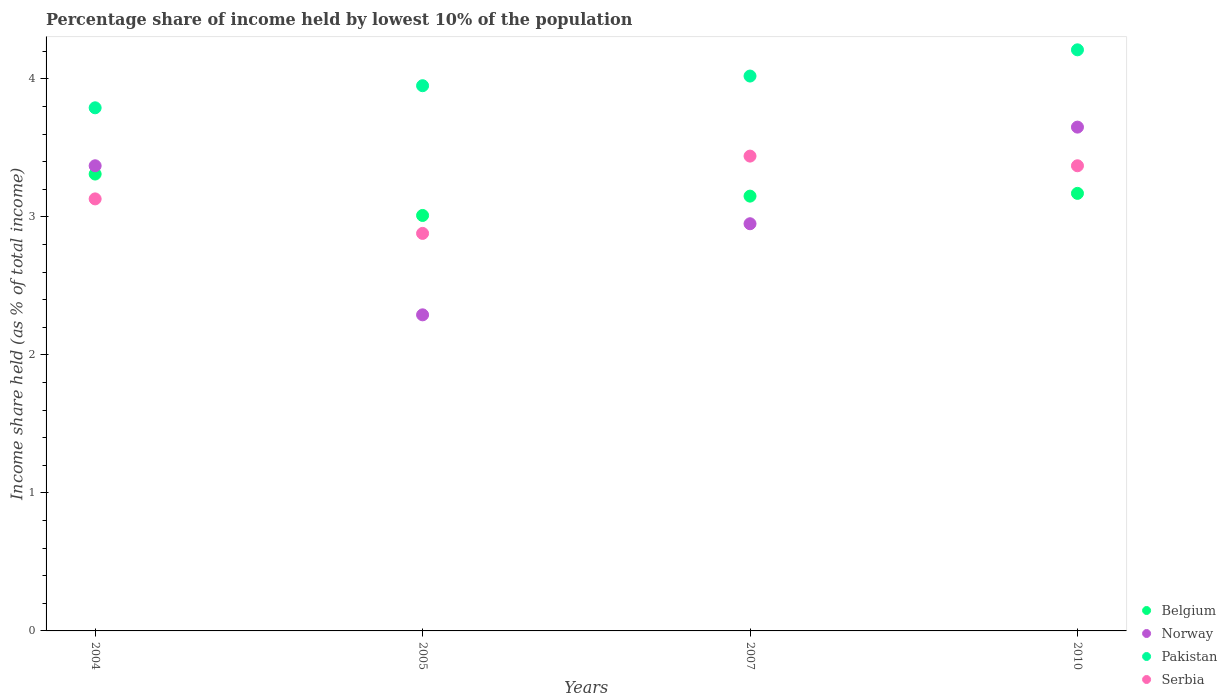Is the number of dotlines equal to the number of legend labels?
Your response must be concise. Yes. What is the percentage share of income held by lowest 10% of the population in Pakistan in 2005?
Offer a terse response. 3.95. Across all years, what is the maximum percentage share of income held by lowest 10% of the population in Belgium?
Offer a very short reply. 3.31. Across all years, what is the minimum percentage share of income held by lowest 10% of the population in Norway?
Offer a very short reply. 2.29. In which year was the percentage share of income held by lowest 10% of the population in Norway maximum?
Make the answer very short. 2010. What is the total percentage share of income held by lowest 10% of the population in Norway in the graph?
Keep it short and to the point. 12.26. What is the difference between the percentage share of income held by lowest 10% of the population in Serbia in 2004 and that in 2005?
Offer a very short reply. 0.25. What is the difference between the percentage share of income held by lowest 10% of the population in Pakistan in 2004 and the percentage share of income held by lowest 10% of the population in Norway in 2010?
Your answer should be compact. 0.14. What is the average percentage share of income held by lowest 10% of the population in Belgium per year?
Provide a short and direct response. 3.16. In the year 2010, what is the difference between the percentage share of income held by lowest 10% of the population in Norway and percentage share of income held by lowest 10% of the population in Serbia?
Give a very brief answer. 0.28. What is the ratio of the percentage share of income held by lowest 10% of the population in Pakistan in 2007 to that in 2010?
Provide a short and direct response. 0.95. What is the difference between the highest and the second highest percentage share of income held by lowest 10% of the population in Belgium?
Give a very brief answer. 0.14. What is the difference between the highest and the lowest percentage share of income held by lowest 10% of the population in Norway?
Give a very brief answer. 1.36. In how many years, is the percentage share of income held by lowest 10% of the population in Belgium greater than the average percentage share of income held by lowest 10% of the population in Belgium taken over all years?
Make the answer very short. 2. Is it the case that in every year, the sum of the percentage share of income held by lowest 10% of the population in Pakistan and percentage share of income held by lowest 10% of the population in Norway  is greater than the sum of percentage share of income held by lowest 10% of the population in Serbia and percentage share of income held by lowest 10% of the population in Belgium?
Provide a short and direct response. No. Is it the case that in every year, the sum of the percentage share of income held by lowest 10% of the population in Norway and percentage share of income held by lowest 10% of the population in Pakistan  is greater than the percentage share of income held by lowest 10% of the population in Serbia?
Keep it short and to the point. Yes. How many dotlines are there?
Your answer should be very brief. 4. Does the graph contain any zero values?
Offer a very short reply. No. Where does the legend appear in the graph?
Provide a short and direct response. Bottom right. How many legend labels are there?
Your answer should be very brief. 4. What is the title of the graph?
Make the answer very short. Percentage share of income held by lowest 10% of the population. What is the label or title of the Y-axis?
Provide a succinct answer. Income share held (as % of total income). What is the Income share held (as % of total income) of Belgium in 2004?
Offer a very short reply. 3.31. What is the Income share held (as % of total income) in Norway in 2004?
Give a very brief answer. 3.37. What is the Income share held (as % of total income) of Pakistan in 2004?
Give a very brief answer. 3.79. What is the Income share held (as % of total income) in Serbia in 2004?
Ensure brevity in your answer.  3.13. What is the Income share held (as % of total income) of Belgium in 2005?
Give a very brief answer. 3.01. What is the Income share held (as % of total income) of Norway in 2005?
Your answer should be compact. 2.29. What is the Income share held (as % of total income) of Pakistan in 2005?
Your answer should be compact. 3.95. What is the Income share held (as % of total income) of Serbia in 2005?
Your response must be concise. 2.88. What is the Income share held (as % of total income) of Belgium in 2007?
Provide a succinct answer. 3.15. What is the Income share held (as % of total income) of Norway in 2007?
Make the answer very short. 2.95. What is the Income share held (as % of total income) of Pakistan in 2007?
Offer a terse response. 4.02. What is the Income share held (as % of total income) of Serbia in 2007?
Your answer should be compact. 3.44. What is the Income share held (as % of total income) in Belgium in 2010?
Give a very brief answer. 3.17. What is the Income share held (as % of total income) in Norway in 2010?
Your answer should be compact. 3.65. What is the Income share held (as % of total income) in Pakistan in 2010?
Ensure brevity in your answer.  4.21. What is the Income share held (as % of total income) in Serbia in 2010?
Give a very brief answer. 3.37. Across all years, what is the maximum Income share held (as % of total income) of Belgium?
Ensure brevity in your answer.  3.31. Across all years, what is the maximum Income share held (as % of total income) in Norway?
Your response must be concise. 3.65. Across all years, what is the maximum Income share held (as % of total income) in Pakistan?
Provide a succinct answer. 4.21. Across all years, what is the maximum Income share held (as % of total income) of Serbia?
Give a very brief answer. 3.44. Across all years, what is the minimum Income share held (as % of total income) of Belgium?
Your answer should be very brief. 3.01. Across all years, what is the minimum Income share held (as % of total income) of Norway?
Your answer should be compact. 2.29. Across all years, what is the minimum Income share held (as % of total income) of Pakistan?
Keep it short and to the point. 3.79. Across all years, what is the minimum Income share held (as % of total income) of Serbia?
Provide a succinct answer. 2.88. What is the total Income share held (as % of total income) of Belgium in the graph?
Provide a succinct answer. 12.64. What is the total Income share held (as % of total income) in Norway in the graph?
Provide a short and direct response. 12.26. What is the total Income share held (as % of total income) of Pakistan in the graph?
Make the answer very short. 15.97. What is the total Income share held (as % of total income) in Serbia in the graph?
Make the answer very short. 12.82. What is the difference between the Income share held (as % of total income) in Belgium in 2004 and that in 2005?
Ensure brevity in your answer.  0.3. What is the difference between the Income share held (as % of total income) in Norway in 2004 and that in 2005?
Provide a short and direct response. 1.08. What is the difference between the Income share held (as % of total income) of Pakistan in 2004 and that in 2005?
Give a very brief answer. -0.16. What is the difference between the Income share held (as % of total income) of Serbia in 2004 and that in 2005?
Your response must be concise. 0.25. What is the difference between the Income share held (as % of total income) in Belgium in 2004 and that in 2007?
Give a very brief answer. 0.16. What is the difference between the Income share held (as % of total income) of Norway in 2004 and that in 2007?
Your answer should be compact. 0.42. What is the difference between the Income share held (as % of total income) of Pakistan in 2004 and that in 2007?
Your answer should be compact. -0.23. What is the difference between the Income share held (as % of total income) of Serbia in 2004 and that in 2007?
Your response must be concise. -0.31. What is the difference between the Income share held (as % of total income) in Belgium in 2004 and that in 2010?
Keep it short and to the point. 0.14. What is the difference between the Income share held (as % of total income) in Norway in 2004 and that in 2010?
Provide a succinct answer. -0.28. What is the difference between the Income share held (as % of total income) of Pakistan in 2004 and that in 2010?
Provide a short and direct response. -0.42. What is the difference between the Income share held (as % of total income) in Serbia in 2004 and that in 2010?
Offer a terse response. -0.24. What is the difference between the Income share held (as % of total income) in Belgium in 2005 and that in 2007?
Your answer should be very brief. -0.14. What is the difference between the Income share held (as % of total income) of Norway in 2005 and that in 2007?
Keep it short and to the point. -0.66. What is the difference between the Income share held (as % of total income) of Pakistan in 2005 and that in 2007?
Provide a succinct answer. -0.07. What is the difference between the Income share held (as % of total income) of Serbia in 2005 and that in 2007?
Keep it short and to the point. -0.56. What is the difference between the Income share held (as % of total income) in Belgium in 2005 and that in 2010?
Offer a very short reply. -0.16. What is the difference between the Income share held (as % of total income) in Norway in 2005 and that in 2010?
Your answer should be very brief. -1.36. What is the difference between the Income share held (as % of total income) of Pakistan in 2005 and that in 2010?
Give a very brief answer. -0.26. What is the difference between the Income share held (as % of total income) of Serbia in 2005 and that in 2010?
Offer a very short reply. -0.49. What is the difference between the Income share held (as % of total income) in Belgium in 2007 and that in 2010?
Your answer should be compact. -0.02. What is the difference between the Income share held (as % of total income) in Norway in 2007 and that in 2010?
Offer a very short reply. -0.7. What is the difference between the Income share held (as % of total income) of Pakistan in 2007 and that in 2010?
Offer a very short reply. -0.19. What is the difference between the Income share held (as % of total income) of Serbia in 2007 and that in 2010?
Your response must be concise. 0.07. What is the difference between the Income share held (as % of total income) of Belgium in 2004 and the Income share held (as % of total income) of Pakistan in 2005?
Your answer should be very brief. -0.64. What is the difference between the Income share held (as % of total income) in Belgium in 2004 and the Income share held (as % of total income) in Serbia in 2005?
Your answer should be very brief. 0.43. What is the difference between the Income share held (as % of total income) in Norway in 2004 and the Income share held (as % of total income) in Pakistan in 2005?
Keep it short and to the point. -0.58. What is the difference between the Income share held (as % of total income) in Norway in 2004 and the Income share held (as % of total income) in Serbia in 2005?
Give a very brief answer. 0.49. What is the difference between the Income share held (as % of total income) of Pakistan in 2004 and the Income share held (as % of total income) of Serbia in 2005?
Make the answer very short. 0.91. What is the difference between the Income share held (as % of total income) in Belgium in 2004 and the Income share held (as % of total income) in Norway in 2007?
Give a very brief answer. 0.36. What is the difference between the Income share held (as % of total income) in Belgium in 2004 and the Income share held (as % of total income) in Pakistan in 2007?
Your answer should be compact. -0.71. What is the difference between the Income share held (as % of total income) of Belgium in 2004 and the Income share held (as % of total income) of Serbia in 2007?
Offer a very short reply. -0.13. What is the difference between the Income share held (as % of total income) of Norway in 2004 and the Income share held (as % of total income) of Pakistan in 2007?
Your answer should be very brief. -0.65. What is the difference between the Income share held (as % of total income) of Norway in 2004 and the Income share held (as % of total income) of Serbia in 2007?
Make the answer very short. -0.07. What is the difference between the Income share held (as % of total income) of Belgium in 2004 and the Income share held (as % of total income) of Norway in 2010?
Offer a very short reply. -0.34. What is the difference between the Income share held (as % of total income) in Belgium in 2004 and the Income share held (as % of total income) in Pakistan in 2010?
Keep it short and to the point. -0.9. What is the difference between the Income share held (as % of total income) of Belgium in 2004 and the Income share held (as % of total income) of Serbia in 2010?
Provide a succinct answer. -0.06. What is the difference between the Income share held (as % of total income) in Norway in 2004 and the Income share held (as % of total income) in Pakistan in 2010?
Provide a succinct answer. -0.84. What is the difference between the Income share held (as % of total income) of Norway in 2004 and the Income share held (as % of total income) of Serbia in 2010?
Provide a short and direct response. 0. What is the difference between the Income share held (as % of total income) in Pakistan in 2004 and the Income share held (as % of total income) in Serbia in 2010?
Make the answer very short. 0.42. What is the difference between the Income share held (as % of total income) of Belgium in 2005 and the Income share held (as % of total income) of Norway in 2007?
Provide a succinct answer. 0.06. What is the difference between the Income share held (as % of total income) of Belgium in 2005 and the Income share held (as % of total income) of Pakistan in 2007?
Keep it short and to the point. -1.01. What is the difference between the Income share held (as % of total income) of Belgium in 2005 and the Income share held (as % of total income) of Serbia in 2007?
Give a very brief answer. -0.43. What is the difference between the Income share held (as % of total income) in Norway in 2005 and the Income share held (as % of total income) in Pakistan in 2007?
Offer a very short reply. -1.73. What is the difference between the Income share held (as % of total income) in Norway in 2005 and the Income share held (as % of total income) in Serbia in 2007?
Ensure brevity in your answer.  -1.15. What is the difference between the Income share held (as % of total income) of Pakistan in 2005 and the Income share held (as % of total income) of Serbia in 2007?
Provide a short and direct response. 0.51. What is the difference between the Income share held (as % of total income) in Belgium in 2005 and the Income share held (as % of total income) in Norway in 2010?
Your answer should be compact. -0.64. What is the difference between the Income share held (as % of total income) of Belgium in 2005 and the Income share held (as % of total income) of Pakistan in 2010?
Your answer should be compact. -1.2. What is the difference between the Income share held (as % of total income) in Belgium in 2005 and the Income share held (as % of total income) in Serbia in 2010?
Make the answer very short. -0.36. What is the difference between the Income share held (as % of total income) in Norway in 2005 and the Income share held (as % of total income) in Pakistan in 2010?
Give a very brief answer. -1.92. What is the difference between the Income share held (as % of total income) in Norway in 2005 and the Income share held (as % of total income) in Serbia in 2010?
Provide a short and direct response. -1.08. What is the difference between the Income share held (as % of total income) of Pakistan in 2005 and the Income share held (as % of total income) of Serbia in 2010?
Offer a very short reply. 0.58. What is the difference between the Income share held (as % of total income) in Belgium in 2007 and the Income share held (as % of total income) in Pakistan in 2010?
Ensure brevity in your answer.  -1.06. What is the difference between the Income share held (as % of total income) in Belgium in 2007 and the Income share held (as % of total income) in Serbia in 2010?
Provide a short and direct response. -0.22. What is the difference between the Income share held (as % of total income) in Norway in 2007 and the Income share held (as % of total income) in Pakistan in 2010?
Provide a short and direct response. -1.26. What is the difference between the Income share held (as % of total income) in Norway in 2007 and the Income share held (as % of total income) in Serbia in 2010?
Ensure brevity in your answer.  -0.42. What is the difference between the Income share held (as % of total income) of Pakistan in 2007 and the Income share held (as % of total income) of Serbia in 2010?
Your answer should be compact. 0.65. What is the average Income share held (as % of total income) of Belgium per year?
Offer a very short reply. 3.16. What is the average Income share held (as % of total income) of Norway per year?
Provide a short and direct response. 3.06. What is the average Income share held (as % of total income) in Pakistan per year?
Offer a very short reply. 3.99. What is the average Income share held (as % of total income) of Serbia per year?
Your answer should be very brief. 3.21. In the year 2004, what is the difference between the Income share held (as % of total income) of Belgium and Income share held (as % of total income) of Norway?
Provide a short and direct response. -0.06. In the year 2004, what is the difference between the Income share held (as % of total income) of Belgium and Income share held (as % of total income) of Pakistan?
Provide a short and direct response. -0.48. In the year 2004, what is the difference between the Income share held (as % of total income) of Belgium and Income share held (as % of total income) of Serbia?
Your response must be concise. 0.18. In the year 2004, what is the difference between the Income share held (as % of total income) of Norway and Income share held (as % of total income) of Pakistan?
Keep it short and to the point. -0.42. In the year 2004, what is the difference between the Income share held (as % of total income) in Norway and Income share held (as % of total income) in Serbia?
Provide a short and direct response. 0.24. In the year 2004, what is the difference between the Income share held (as % of total income) in Pakistan and Income share held (as % of total income) in Serbia?
Keep it short and to the point. 0.66. In the year 2005, what is the difference between the Income share held (as % of total income) in Belgium and Income share held (as % of total income) in Norway?
Your answer should be compact. 0.72. In the year 2005, what is the difference between the Income share held (as % of total income) of Belgium and Income share held (as % of total income) of Pakistan?
Provide a succinct answer. -0.94. In the year 2005, what is the difference between the Income share held (as % of total income) in Belgium and Income share held (as % of total income) in Serbia?
Your answer should be compact. 0.13. In the year 2005, what is the difference between the Income share held (as % of total income) in Norway and Income share held (as % of total income) in Pakistan?
Your response must be concise. -1.66. In the year 2005, what is the difference between the Income share held (as % of total income) of Norway and Income share held (as % of total income) of Serbia?
Keep it short and to the point. -0.59. In the year 2005, what is the difference between the Income share held (as % of total income) of Pakistan and Income share held (as % of total income) of Serbia?
Provide a short and direct response. 1.07. In the year 2007, what is the difference between the Income share held (as % of total income) of Belgium and Income share held (as % of total income) of Pakistan?
Offer a terse response. -0.87. In the year 2007, what is the difference between the Income share held (as % of total income) in Belgium and Income share held (as % of total income) in Serbia?
Provide a short and direct response. -0.29. In the year 2007, what is the difference between the Income share held (as % of total income) in Norway and Income share held (as % of total income) in Pakistan?
Your response must be concise. -1.07. In the year 2007, what is the difference between the Income share held (as % of total income) in Norway and Income share held (as % of total income) in Serbia?
Make the answer very short. -0.49. In the year 2007, what is the difference between the Income share held (as % of total income) in Pakistan and Income share held (as % of total income) in Serbia?
Your response must be concise. 0.58. In the year 2010, what is the difference between the Income share held (as % of total income) of Belgium and Income share held (as % of total income) of Norway?
Offer a very short reply. -0.48. In the year 2010, what is the difference between the Income share held (as % of total income) of Belgium and Income share held (as % of total income) of Pakistan?
Make the answer very short. -1.04. In the year 2010, what is the difference between the Income share held (as % of total income) of Belgium and Income share held (as % of total income) of Serbia?
Provide a short and direct response. -0.2. In the year 2010, what is the difference between the Income share held (as % of total income) of Norway and Income share held (as % of total income) of Pakistan?
Your answer should be very brief. -0.56. In the year 2010, what is the difference between the Income share held (as % of total income) of Norway and Income share held (as % of total income) of Serbia?
Your answer should be very brief. 0.28. In the year 2010, what is the difference between the Income share held (as % of total income) of Pakistan and Income share held (as % of total income) of Serbia?
Ensure brevity in your answer.  0.84. What is the ratio of the Income share held (as % of total income) in Belgium in 2004 to that in 2005?
Keep it short and to the point. 1.1. What is the ratio of the Income share held (as % of total income) of Norway in 2004 to that in 2005?
Provide a short and direct response. 1.47. What is the ratio of the Income share held (as % of total income) of Pakistan in 2004 to that in 2005?
Offer a terse response. 0.96. What is the ratio of the Income share held (as % of total income) of Serbia in 2004 to that in 2005?
Make the answer very short. 1.09. What is the ratio of the Income share held (as % of total income) in Belgium in 2004 to that in 2007?
Provide a short and direct response. 1.05. What is the ratio of the Income share held (as % of total income) in Norway in 2004 to that in 2007?
Offer a terse response. 1.14. What is the ratio of the Income share held (as % of total income) in Pakistan in 2004 to that in 2007?
Your response must be concise. 0.94. What is the ratio of the Income share held (as % of total income) of Serbia in 2004 to that in 2007?
Offer a terse response. 0.91. What is the ratio of the Income share held (as % of total income) of Belgium in 2004 to that in 2010?
Make the answer very short. 1.04. What is the ratio of the Income share held (as % of total income) of Norway in 2004 to that in 2010?
Offer a very short reply. 0.92. What is the ratio of the Income share held (as % of total income) in Pakistan in 2004 to that in 2010?
Your answer should be very brief. 0.9. What is the ratio of the Income share held (as % of total income) of Serbia in 2004 to that in 2010?
Ensure brevity in your answer.  0.93. What is the ratio of the Income share held (as % of total income) of Belgium in 2005 to that in 2007?
Ensure brevity in your answer.  0.96. What is the ratio of the Income share held (as % of total income) in Norway in 2005 to that in 2007?
Your answer should be compact. 0.78. What is the ratio of the Income share held (as % of total income) of Pakistan in 2005 to that in 2007?
Your answer should be very brief. 0.98. What is the ratio of the Income share held (as % of total income) of Serbia in 2005 to that in 2007?
Keep it short and to the point. 0.84. What is the ratio of the Income share held (as % of total income) in Belgium in 2005 to that in 2010?
Ensure brevity in your answer.  0.95. What is the ratio of the Income share held (as % of total income) in Norway in 2005 to that in 2010?
Make the answer very short. 0.63. What is the ratio of the Income share held (as % of total income) of Pakistan in 2005 to that in 2010?
Keep it short and to the point. 0.94. What is the ratio of the Income share held (as % of total income) in Serbia in 2005 to that in 2010?
Provide a succinct answer. 0.85. What is the ratio of the Income share held (as % of total income) of Norway in 2007 to that in 2010?
Provide a short and direct response. 0.81. What is the ratio of the Income share held (as % of total income) of Pakistan in 2007 to that in 2010?
Your answer should be very brief. 0.95. What is the ratio of the Income share held (as % of total income) of Serbia in 2007 to that in 2010?
Offer a terse response. 1.02. What is the difference between the highest and the second highest Income share held (as % of total income) of Belgium?
Your answer should be very brief. 0.14. What is the difference between the highest and the second highest Income share held (as % of total income) in Norway?
Your answer should be compact. 0.28. What is the difference between the highest and the second highest Income share held (as % of total income) of Pakistan?
Make the answer very short. 0.19. What is the difference between the highest and the second highest Income share held (as % of total income) of Serbia?
Offer a very short reply. 0.07. What is the difference between the highest and the lowest Income share held (as % of total income) in Belgium?
Your answer should be very brief. 0.3. What is the difference between the highest and the lowest Income share held (as % of total income) of Norway?
Provide a short and direct response. 1.36. What is the difference between the highest and the lowest Income share held (as % of total income) of Pakistan?
Provide a short and direct response. 0.42. What is the difference between the highest and the lowest Income share held (as % of total income) of Serbia?
Provide a succinct answer. 0.56. 